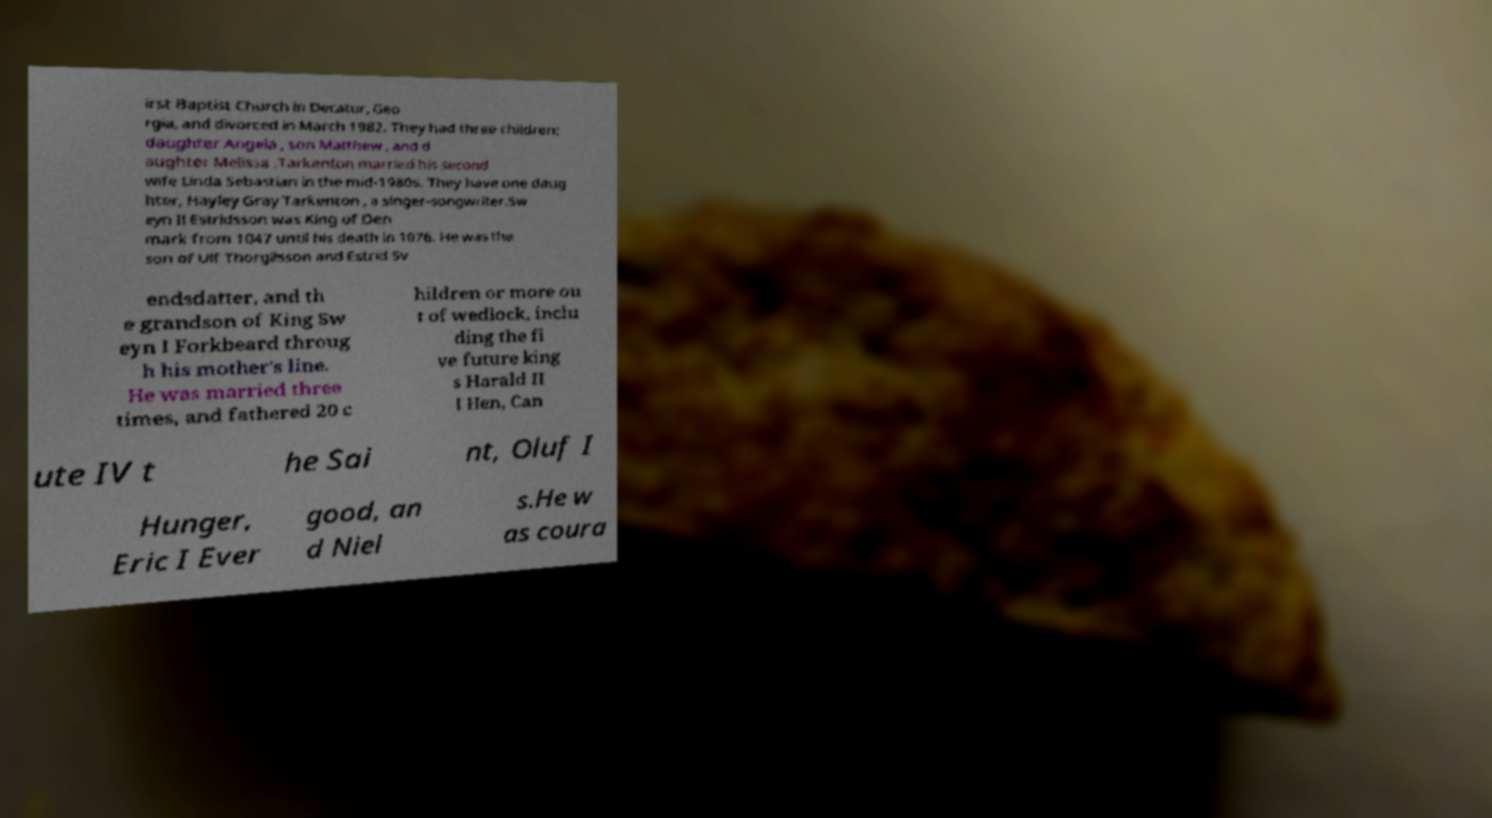Could you extract and type out the text from this image? irst Baptist Church in Decatur, Geo rgia, and divorced in March 1982. They had three children: daughter Angela , son Matthew , and d aughter Melissa .Tarkenton married his second wife Linda Sebastian in the mid-1980s. They have one daug hter, Hayley Gray Tarkenton , a singer-songwriter.Sw eyn II Estridsson was King of Den mark from 1047 until his death in 1076. He was the son of Ulf Thorgilsson and Estrid Sv endsdatter, and th e grandson of King Sw eyn I Forkbeard throug h his mother's line. He was married three times, and fathered 20 c hildren or more ou t of wedlock, inclu ding the fi ve future king s Harald II I Hen, Can ute IV t he Sai nt, Oluf I Hunger, Eric I Ever good, an d Niel s.He w as coura 